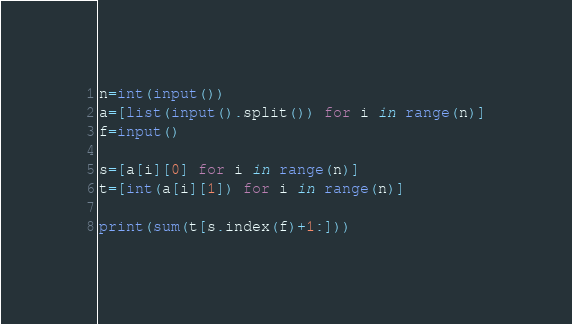<code> <loc_0><loc_0><loc_500><loc_500><_Python_>n=int(input())
a=[list(input().split()) for i in range(n)]
f=input()

s=[a[i][0] for i in range(n)]
t=[int(a[i][1]) for i in range(n)]

print(sum(t[s.index(f)+1:]))</code> 